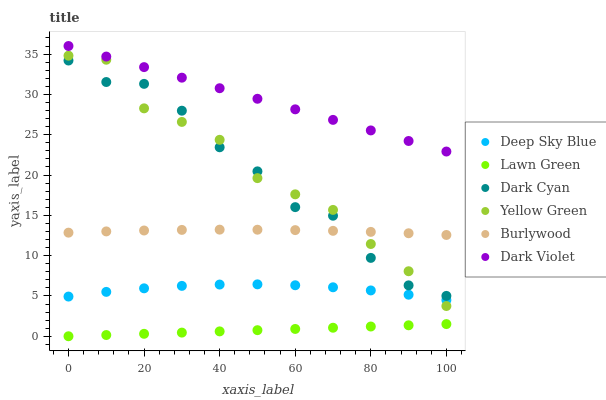Does Lawn Green have the minimum area under the curve?
Answer yes or no. Yes. Does Dark Violet have the maximum area under the curve?
Answer yes or no. Yes. Does Yellow Green have the minimum area under the curve?
Answer yes or no. No. Does Yellow Green have the maximum area under the curve?
Answer yes or no. No. Is Lawn Green the smoothest?
Answer yes or no. Yes. Is Dark Cyan the roughest?
Answer yes or no. Yes. Is Yellow Green the smoothest?
Answer yes or no. No. Is Yellow Green the roughest?
Answer yes or no. No. Does Lawn Green have the lowest value?
Answer yes or no. Yes. Does Yellow Green have the lowest value?
Answer yes or no. No. Does Dark Violet have the highest value?
Answer yes or no. Yes. Does Yellow Green have the highest value?
Answer yes or no. No. Is Deep Sky Blue less than Burlywood?
Answer yes or no. Yes. Is Yellow Green greater than Lawn Green?
Answer yes or no. Yes. Does Burlywood intersect Yellow Green?
Answer yes or no. Yes. Is Burlywood less than Yellow Green?
Answer yes or no. No. Is Burlywood greater than Yellow Green?
Answer yes or no. No. Does Deep Sky Blue intersect Burlywood?
Answer yes or no. No. 